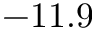Convert formula to latex. <formula><loc_0><loc_0><loc_500><loc_500>- 1 1 . 9</formula> 